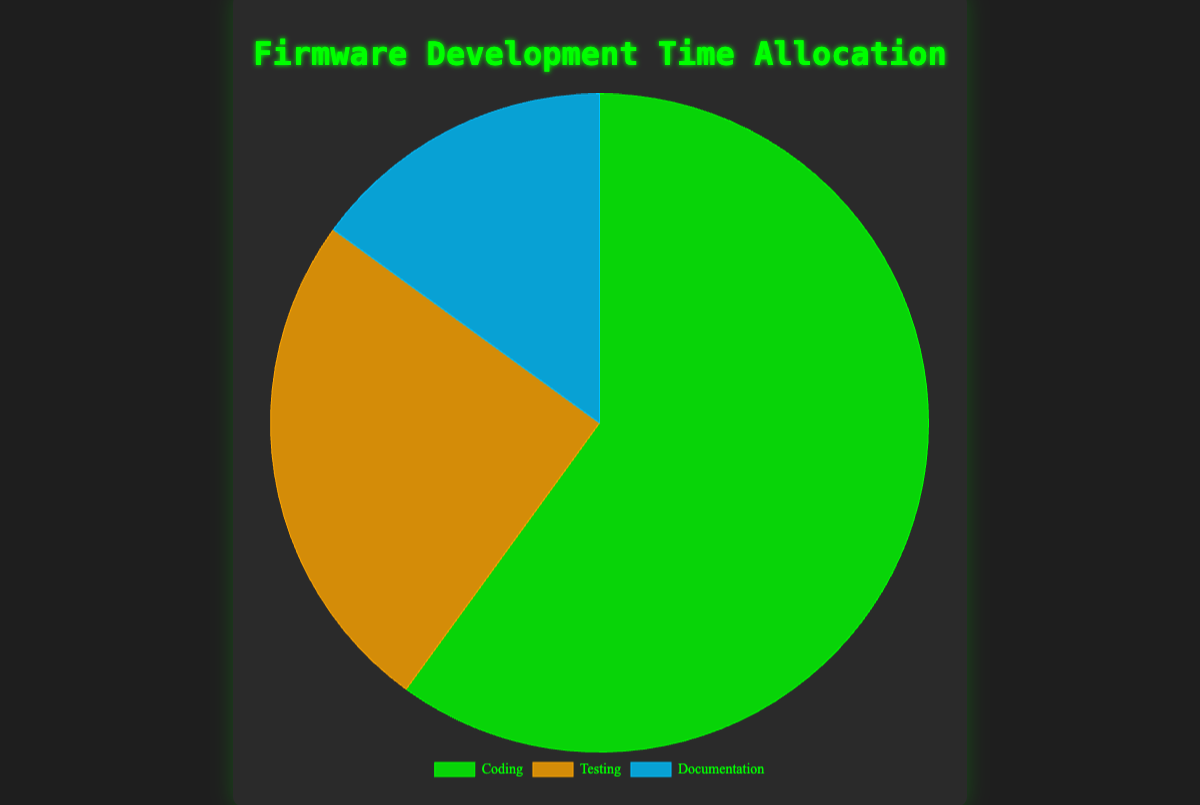Which activity takes up the most time? The pie chart shows three activities with their respective time allocations. Coding has the largest portion of the pie chart.
Answer: Coding What is the combined time allocation for Testing and Documentation? The pie chart shows Testing at 25% and Documentation at 15%. Adding these values gives 25 + 15 = 40%.
Answer: 40% How much more time is spent on Coding compared to Documentation? The pie chart shows Coding at 60% and Documentation at 15%. Subtracting these values gives 60 - 15 = 45%.
Answer: 45% Which two activities combined have a larger time allocation than Coding alone? Coding is 60%. The combined time allocations of Testing (25%) and Documentation (15%) are 25 + 15 = 40%, which is still less than 60%. Therefore, no two activities combined exceed Coding.
Answer: None How does the time allocation for Testing compare to Documentation? The pie chart shows Testing at 25% and Documentation at 15%. Testing is greater than Documentation.
Answer: Testing > Documentation What is the average time allocation for Coding and Documentation? The pie chart shows Coding at 60% and Documentation at 15%. Adding these values and dividing by 2 gives (60 + 15)/2 = 37.5%.
Answer: 37.5% Which activity has the smallest time allocation? The pie chart shows three activities with their respective time allocations. Documentation has the smallest portion of the pie chart.
Answer: Documentation If you combine the time allocations for Testing and Documentation, is it more or less than Coding? The pie chart shows Testing at 25% and Documentation at 15%, which combined gives 40%. Coding is at 60%. Therefore, 40% is less than 60%.
Answer: Less What color represents the activity with the highest time allocation? The pie chart shows that Coding has the highest time allocation and is represented in green.
Answer: Green How much time is not dedicated to Coding? The pie chart shows that Coding is 60%. The remaining time is allocated to Testing and Documentation, which combined is 100 - 60 = 40%.
Answer: 40% 